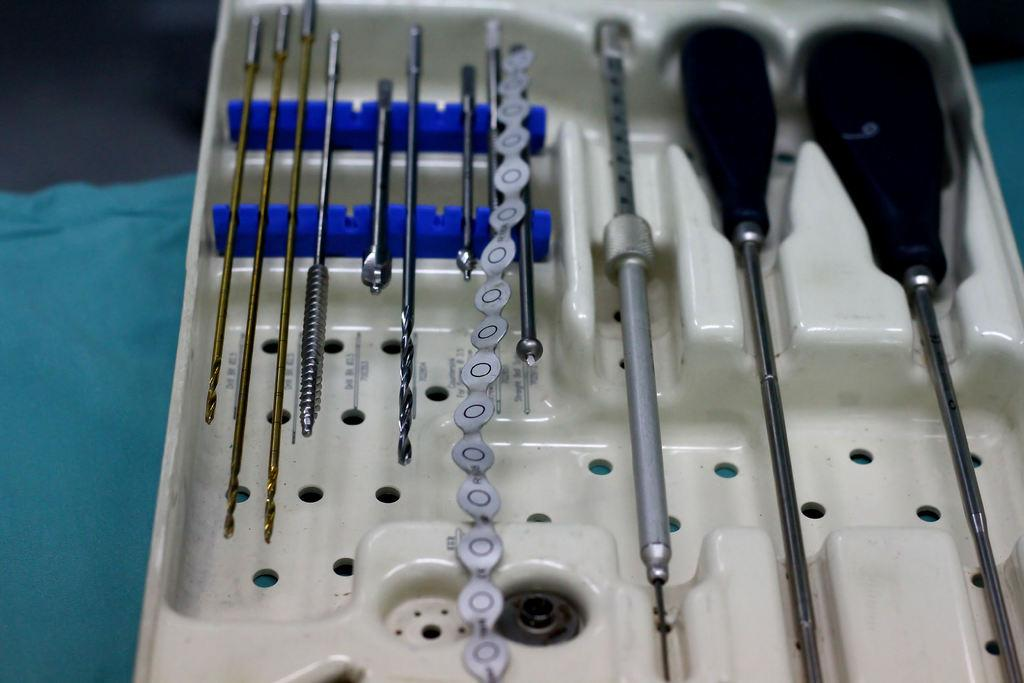What object is the main focus of the image? There is a box in the image. What can be found inside the box? There are tools inside the box. What is placed under the box? There is a cloth under the box. What type of gold can be seen on the tools inside the box? There is no gold present on the tools inside the box; the tools are not described as having any gold components. 